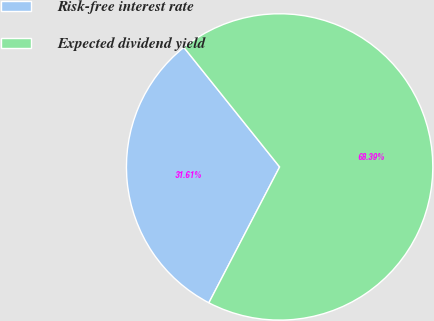Convert chart. <chart><loc_0><loc_0><loc_500><loc_500><pie_chart><fcel>Risk-free interest rate<fcel>Expected dividend yield<nl><fcel>31.61%<fcel>68.39%<nl></chart> 